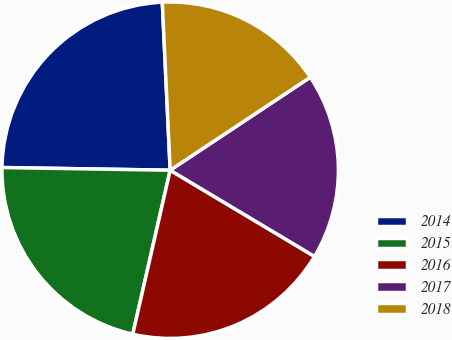Convert chart. <chart><loc_0><loc_0><loc_500><loc_500><pie_chart><fcel>2014<fcel>2015<fcel>2016<fcel>2017<fcel>2018<nl><fcel>24.0%<fcel>21.68%<fcel>20.0%<fcel>17.89%<fcel>16.42%<nl></chart> 